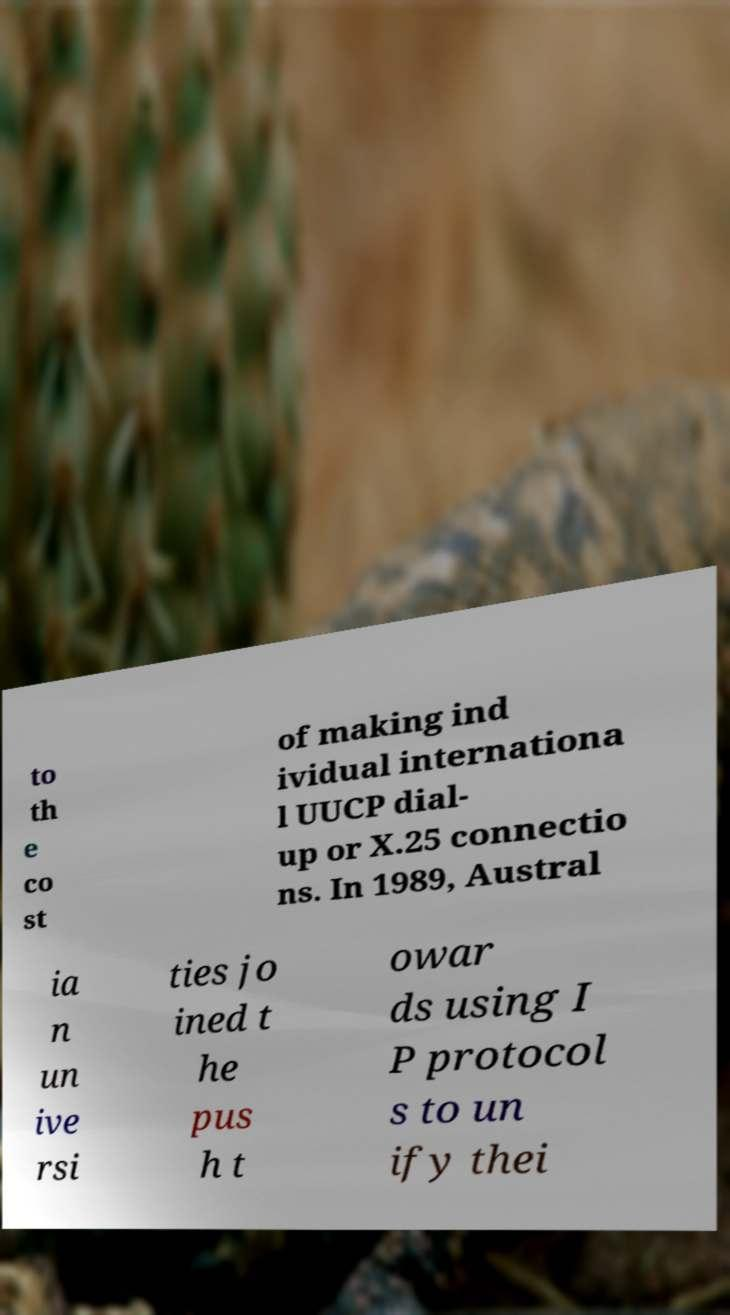What messages or text are displayed in this image? I need them in a readable, typed format. to th e co st of making ind ividual internationa l UUCP dial- up or X.25 connectio ns. In 1989, Austral ia n un ive rsi ties jo ined t he pus h t owar ds using I P protocol s to un ify thei 